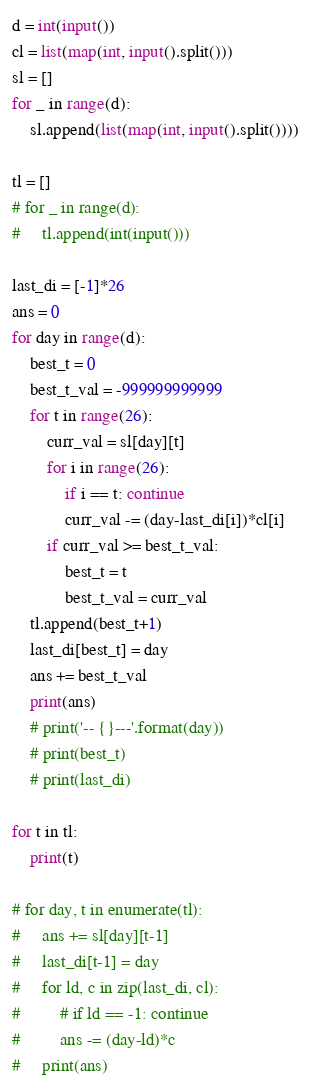<code> <loc_0><loc_0><loc_500><loc_500><_Python_>d = int(input())
cl = list(map(int, input().split()))
sl = []
for _ in range(d):
    sl.append(list(map(int, input().split())))

tl = []
# for _ in range(d):
#     tl.append(int(input()))

last_di = [-1]*26
ans = 0
for day in range(d):
    best_t = 0
    best_t_val = -999999999999
    for t in range(26):
        curr_val = sl[day][t]
        for i in range(26):
            if i == t: continue
            curr_val -= (day-last_di[i])*cl[i]
        if curr_val >= best_t_val:
            best_t = t
            best_t_val = curr_val
    tl.append(best_t+1)
    last_di[best_t] = day
    ans += best_t_val
    print(ans)
    # print('-- {}---'.format(day))
    # print(best_t)
    # print(last_di)

for t in tl:
    print(t)

# for day, t in enumerate(tl):
#     ans += sl[day][t-1]
#     last_di[t-1] = day
#     for ld, c in zip(last_di, cl):
#         # if ld == -1: continue
#         ans -= (day-ld)*c
#     print(ans)</code> 